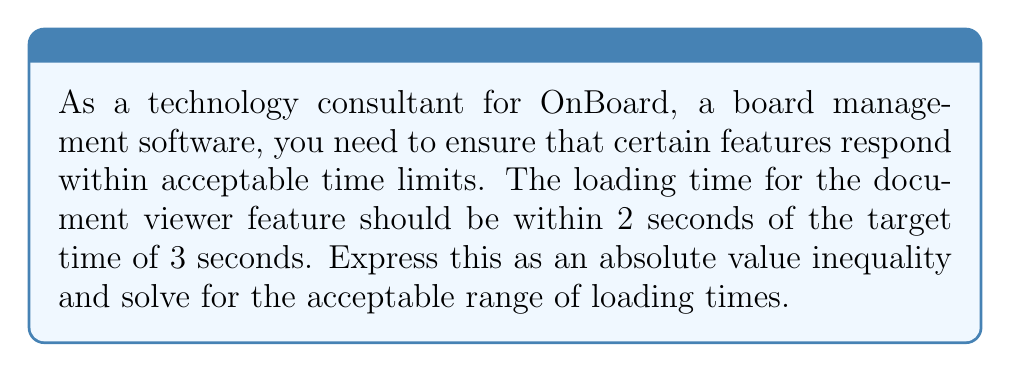Could you help me with this problem? Let's approach this step-by-step:

1) Let $x$ represent the actual loading time in seconds.

2) The target time is 3 seconds, and the actual time should be within 2 seconds of this target.

3) We can express this as an absolute value inequality:

   $$|x - 3| \leq 2$$

4) To solve this inequality, we need to consider two cases:

   Case 1: $x - 3 \leq 2$
   Case 2: $-(x - 3) \leq 2$

5) Solving Case 1:
   $x - 3 \leq 2$
   $x \leq 5$

6) Solving Case 2:
   $-(x - 3) \leq 2$
   $-x + 3 \leq 2$
   $-x \leq -1$
   $x \geq 1$

7) Combining the results from both cases:

   $$1 \leq x \leq 5$$

This means the acceptable range of loading times is between 1 and 5 seconds, inclusive.
Answer: The acceptable range of loading times for the document viewer feature is $1 \leq x \leq 5$ seconds, where $x$ is the actual loading time. 